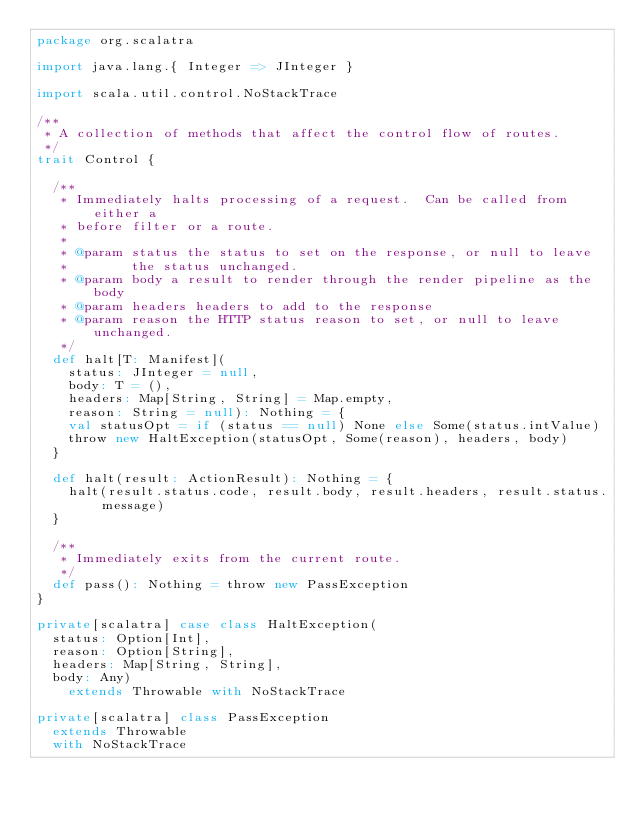Convert code to text. <code><loc_0><loc_0><loc_500><loc_500><_Scala_>package org.scalatra

import java.lang.{ Integer => JInteger }

import scala.util.control.NoStackTrace

/**
 * A collection of methods that affect the control flow of routes.
 */
trait Control {

  /**
   * Immediately halts processing of a request.  Can be called from either a
   * before filter or a route.
   *
   * @param status the status to set on the response, or null to leave
   *        the status unchanged.
   * @param body a result to render through the render pipeline as the body
   * @param headers headers to add to the response
   * @param reason the HTTP status reason to set, or null to leave unchanged.
   */
  def halt[T: Manifest](
    status: JInteger = null,
    body: T = (),
    headers: Map[String, String] = Map.empty,
    reason: String = null): Nothing = {
    val statusOpt = if (status == null) None else Some(status.intValue)
    throw new HaltException(statusOpt, Some(reason), headers, body)
  }

  def halt(result: ActionResult): Nothing = {
    halt(result.status.code, result.body, result.headers, result.status.message)
  }

  /**
   * Immediately exits from the current route.
   */
  def pass(): Nothing = throw new PassException
}

private[scalatra] case class HaltException(
  status: Option[Int],
  reason: Option[String],
  headers: Map[String, String],
  body: Any)
    extends Throwable with NoStackTrace

private[scalatra] class PassException
  extends Throwable
  with NoStackTrace
</code> 